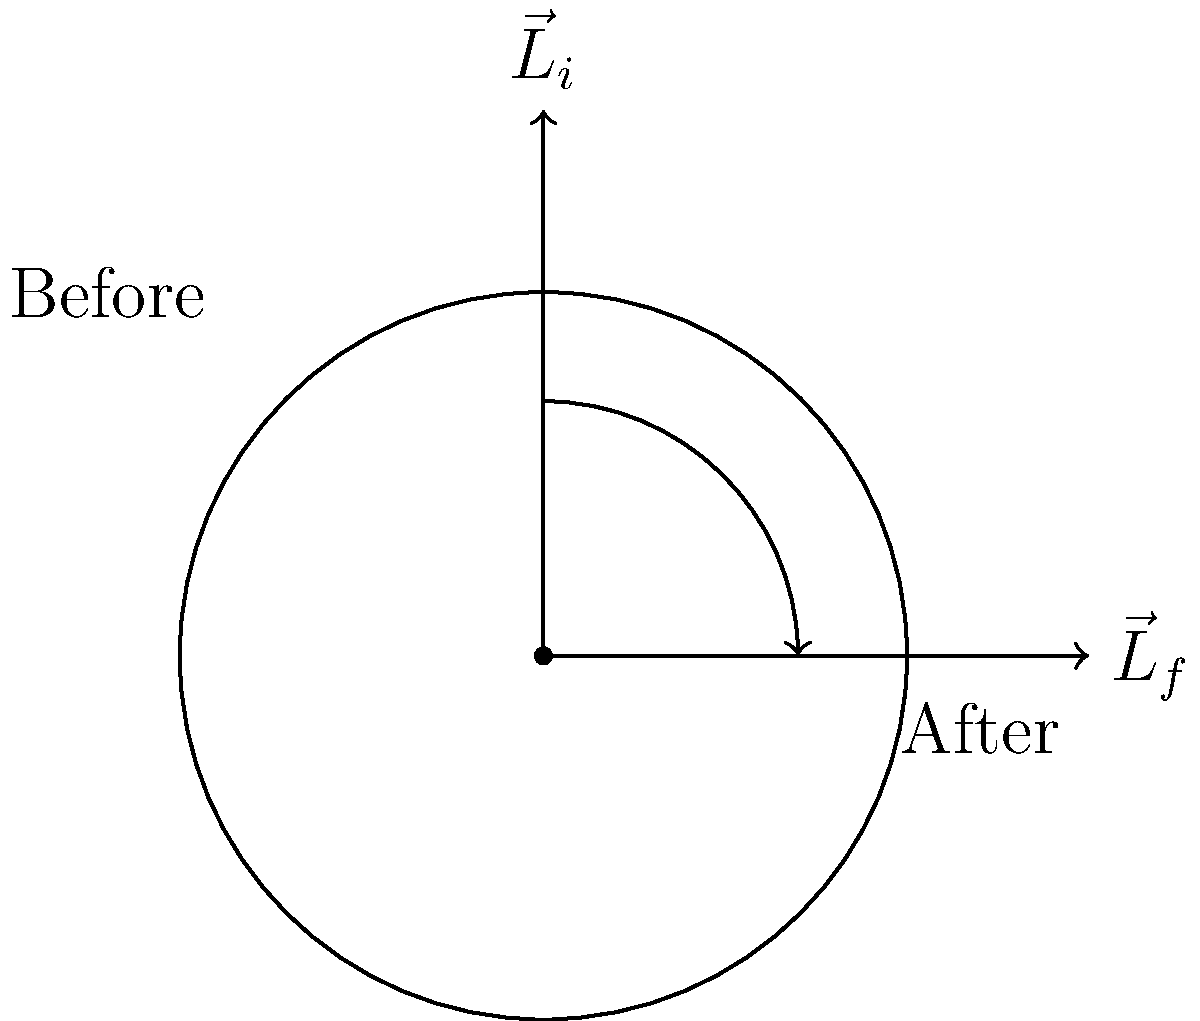At your latest party, you notice the spinning disco ball suddenly changes its axis of rotation by 90 degrees due to a malfunction. If the ball's angular speed remains constant, how does the magnitude of its angular momentum change? Let's approach this step-by-step:

1. Recall that angular momentum $\vec{L}$ is given by $\vec{L} = I\vec{\omega}$, where $I$ is the moment of inertia and $\vec{\omega}$ is the angular velocity vector.

2. The disco ball is spherical, so its moment of inertia remains constant regardless of the axis of rotation.

3. We're told that the angular speed (magnitude of $\vec{\omega}$) remains constant.

4. The key change is in the direction of $\vec{\omega}$, which rotates by 90 degrees.

5. Since $\vec{L} = I\vec{\omega}$, and both $I$ and $|\vec{\omega}|$ are constant, the magnitude of $\vec{L}$ must also remain constant.

6. The conservation of angular momentum principle states that in the absence of external torques, the total angular momentum of a system remains constant.

7. In this case, while the direction of $\vec{L}$ changes (as shown in the diagram), its magnitude remains the same.

Therefore, despite the change in the axis of rotation, the magnitude of the angular momentum does not change.
Answer: The magnitude of angular momentum remains constant. 